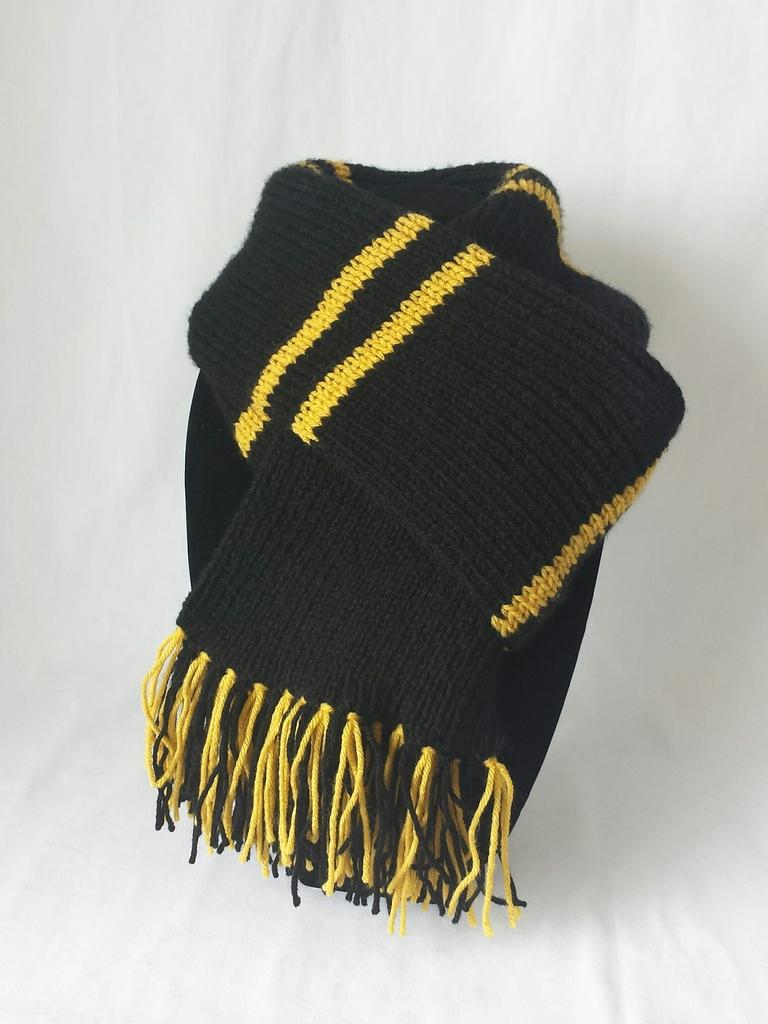What is the main subject in the center of the image? There is a black color scarf in the center of the image. What is the color of the surface on which the scarf is placed? The scarf is on a white color surface. How many apples are visible on the white color surface in the image? There are no apples present in the image. Is there a market visible in the image? There is no market present in the image. 